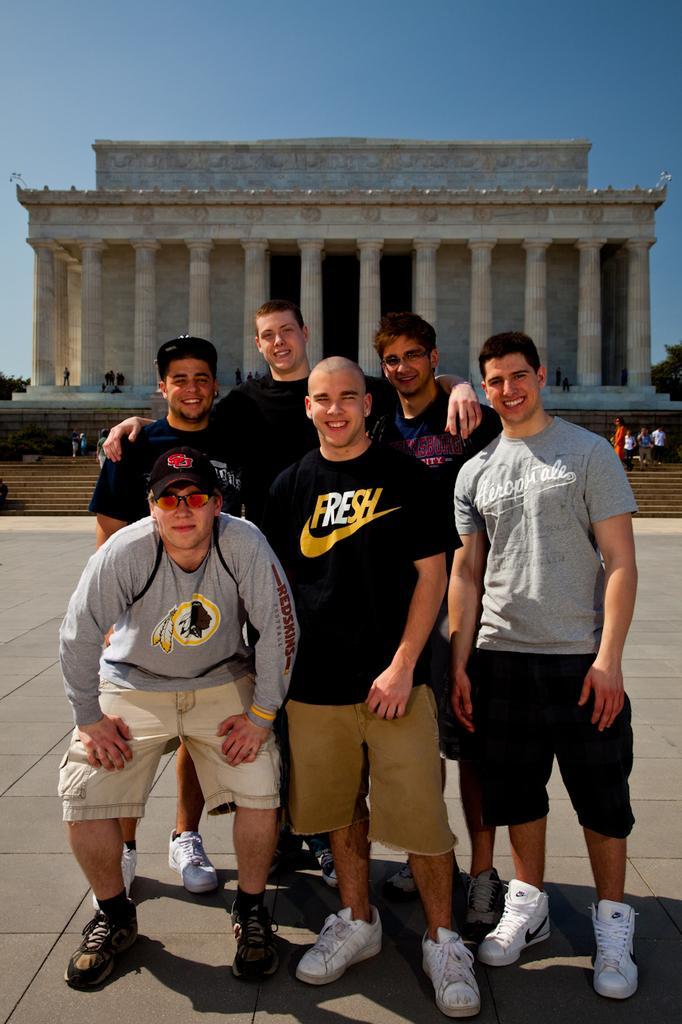Describe this image in one or two sentences. In this image there are group of persons standing and smiling, there is a building behind the persons, there is a staircase, there are persons on the staircase, there is the sky, towards the right of the image there is a tree truncated, towards the left of the image there is a tree truncated. 